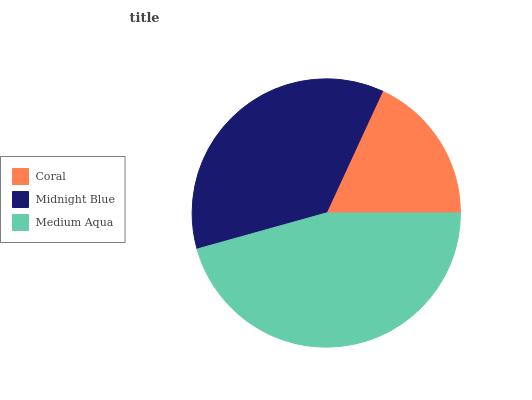Is Coral the minimum?
Answer yes or no. Yes. Is Medium Aqua the maximum?
Answer yes or no. Yes. Is Midnight Blue the minimum?
Answer yes or no. No. Is Midnight Blue the maximum?
Answer yes or no. No. Is Midnight Blue greater than Coral?
Answer yes or no. Yes. Is Coral less than Midnight Blue?
Answer yes or no. Yes. Is Coral greater than Midnight Blue?
Answer yes or no. No. Is Midnight Blue less than Coral?
Answer yes or no. No. Is Midnight Blue the high median?
Answer yes or no. Yes. Is Midnight Blue the low median?
Answer yes or no. Yes. Is Coral the high median?
Answer yes or no. No. Is Coral the low median?
Answer yes or no. No. 